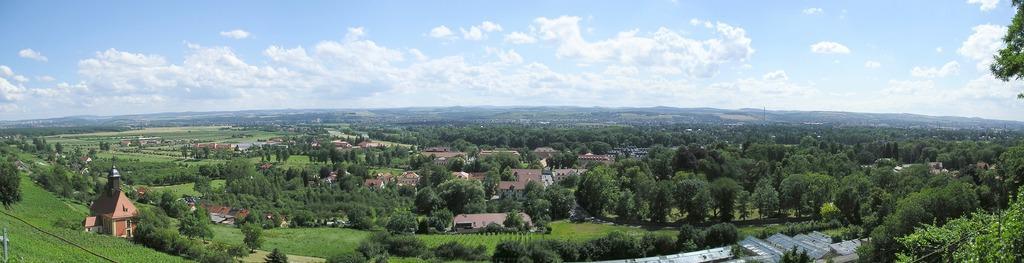In one or two sentences, can you explain what this image depicts? There are trees, buildings and grass. 